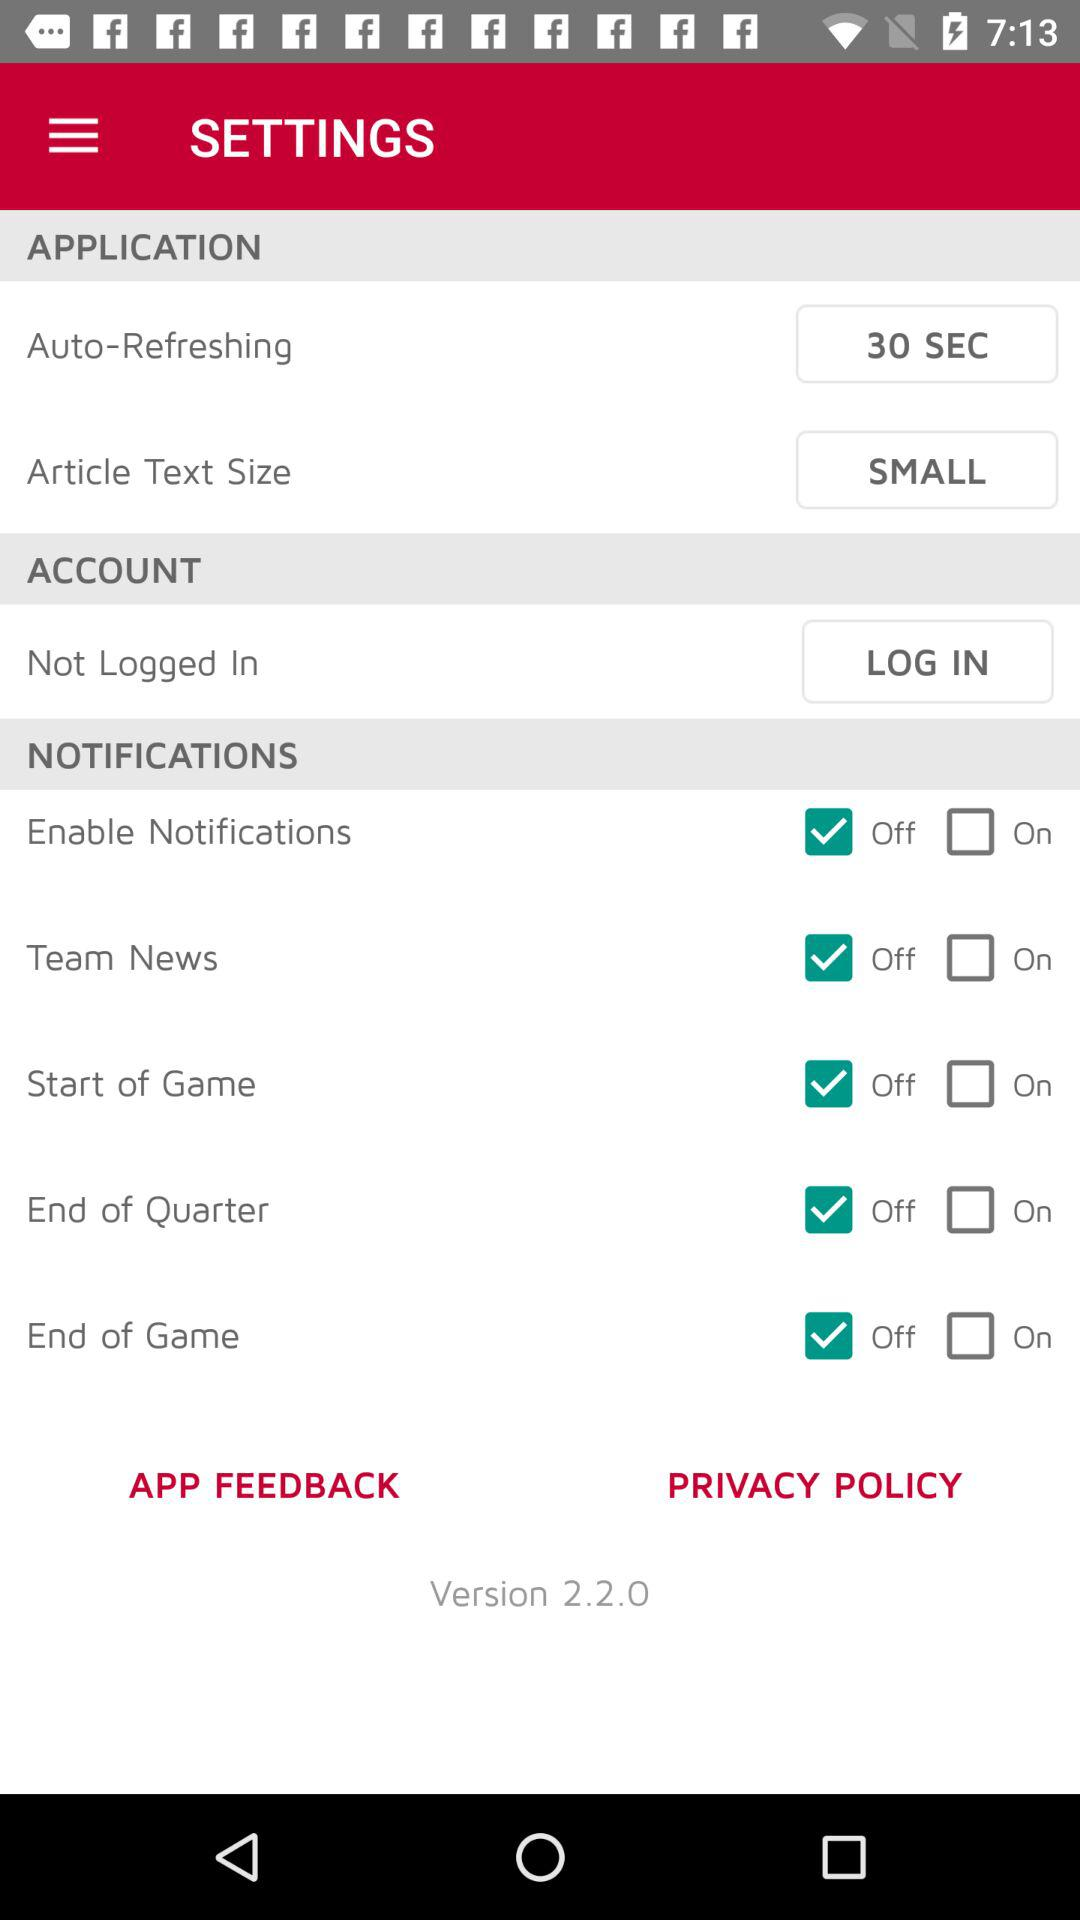How many seconds are fixed for auto-refreshing? For auto-refreshing, 30 seconds are fixed. 